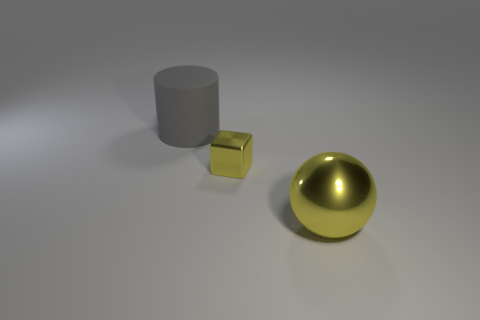There is a object that is both in front of the gray object and to the left of the large shiny thing; how big is it? The object in question appears to be a small cube, significantly smaller than both the gray cylindrical object and the large shiny sphere to its right. Its exact dimensions cannot be determined from the image alone, but its scale in comparison to the other objects suggests it is quite diminutive. 